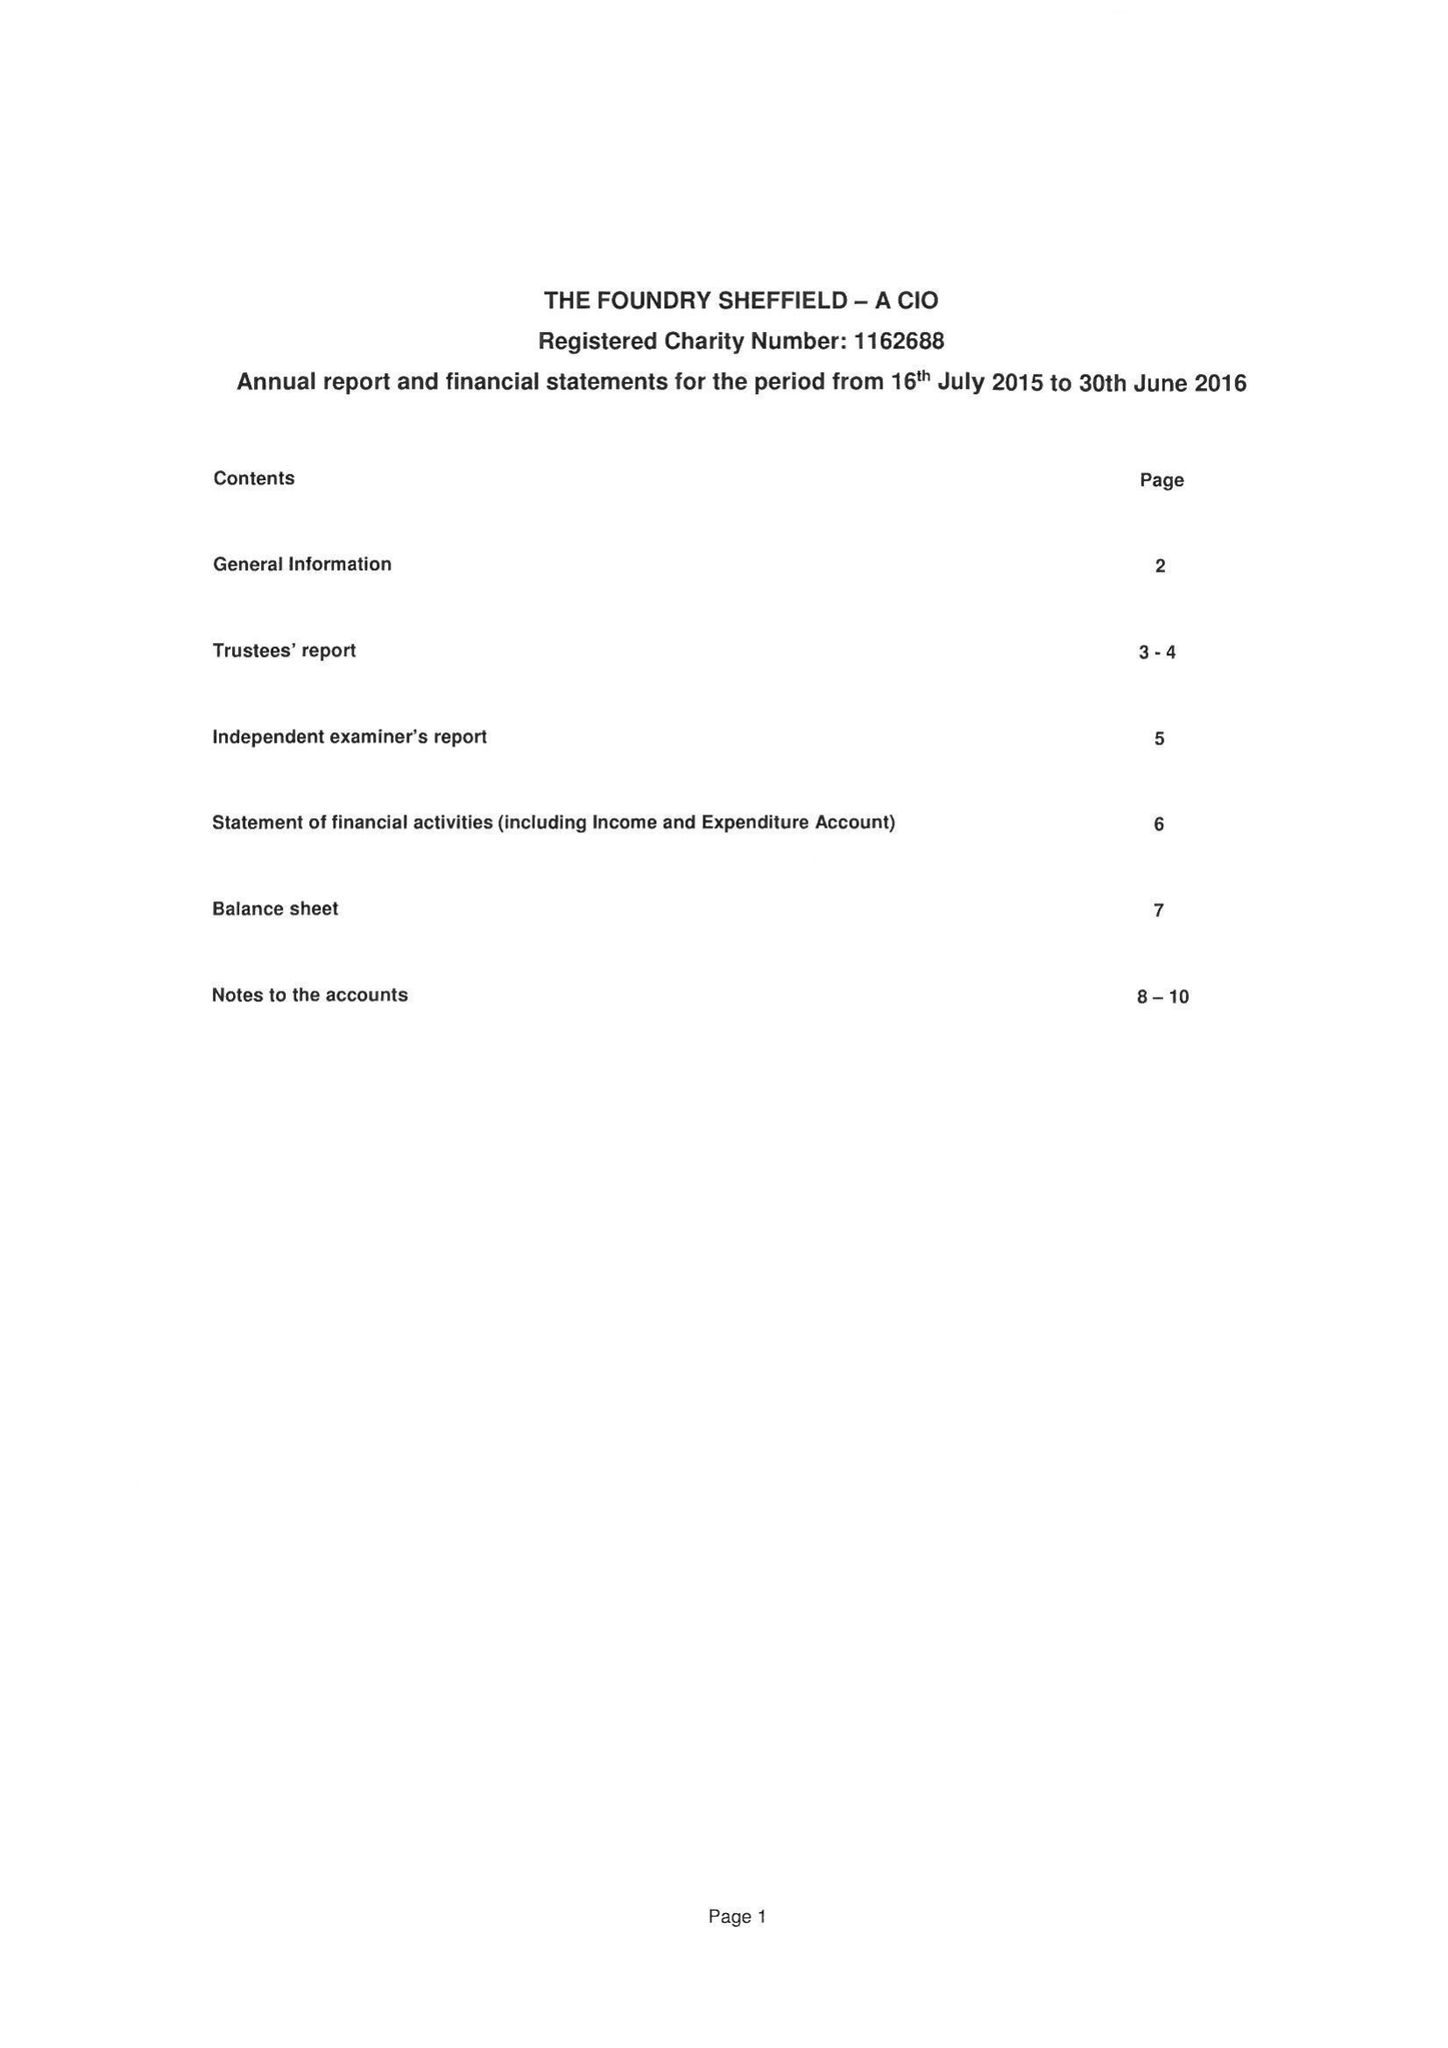What is the value for the income_annually_in_british_pounds?
Answer the question using a single word or phrase. 26333.00 